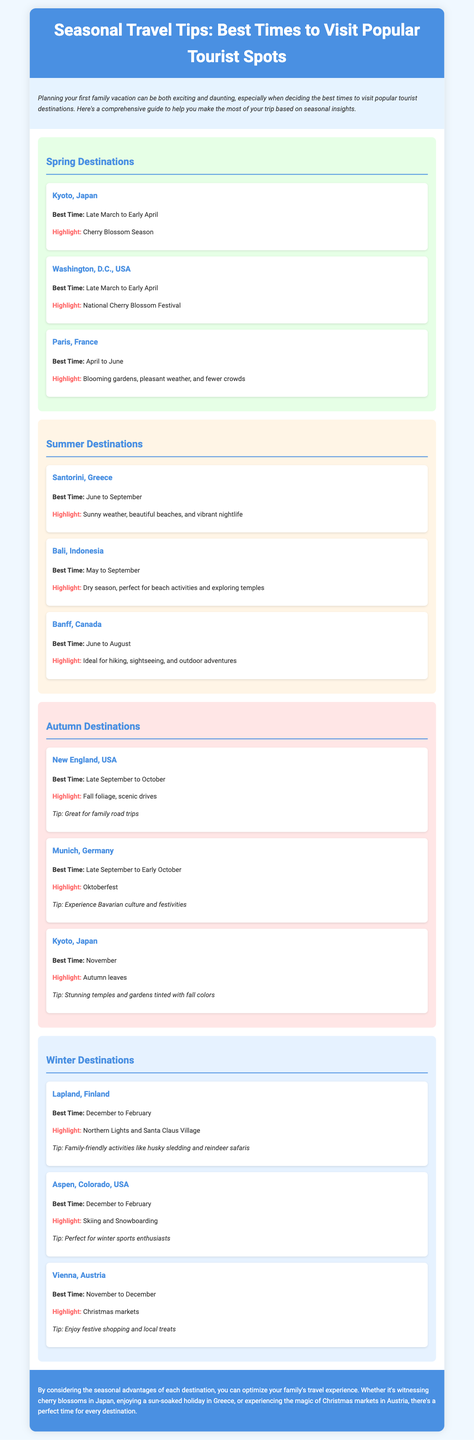What is the best time to visit Kyoto, Japan? The document states that the best time to visit Kyoto, Japan is from late March to early April.
Answer: Late March to Early April What highlight is associated with Washington, D.C. in spring? The document indicates that the highlight for Washington, D.C. is the National Cherry Blossom Festival.
Answer: National Cherry Blossom Festival During which months is Santorini, Greece best to visit? The best time to visit Santorini, Greece is mentioned as June to September.
Answer: June to September What is a tip for visiting New England, USA in autumn? According to the document, a tip for visiting New England is that it is great for family road trips.
Answer: Great for family road trips What activity can families experience in Lapland, Finland during winter? The document highlights family-friendly activities like husky sledding and reindeer safaris available in Lapland, Finland.
Answer: Husky sledding and reindeer safaris Which season is recommended for visiting Banff, Canada? The document suggests that the best season to visit Banff, Canada is summer.
Answer: Summer What highlight is found in Vienna, Austria during winter? The focus for winter in Vienna, Austria is on the Christmas markets.
Answer: Christmas markets What is a highlight of autumn in Kyoto, Japan? The document highlights the stunning autumn leaves in Kyoto, Japan during November.
Answer: Autumn leaves 